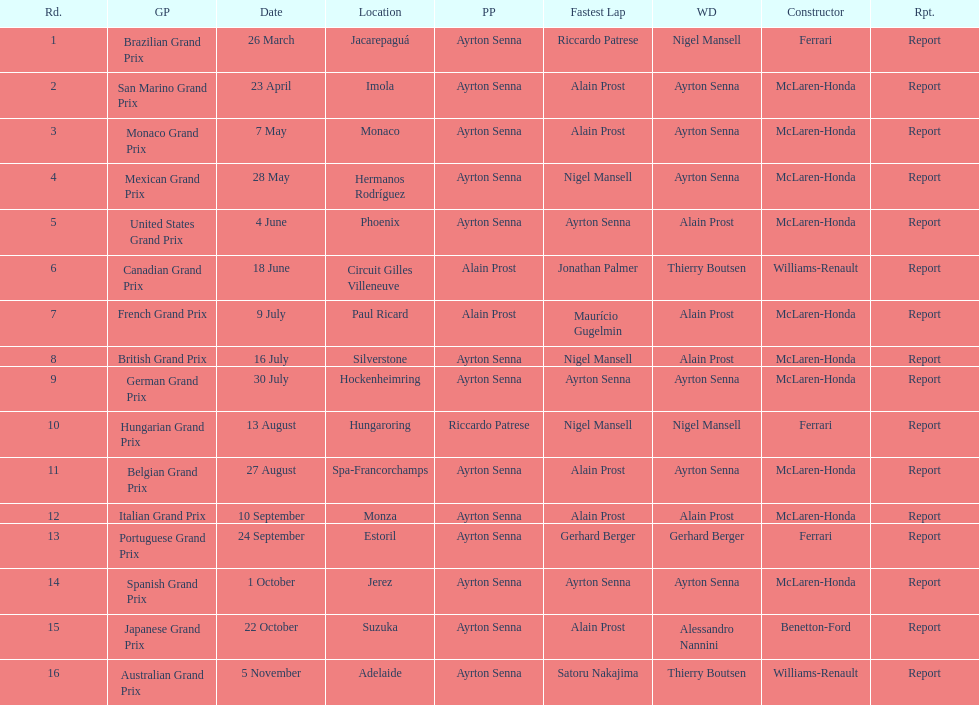What grand prix was before the san marino grand prix? Brazilian Grand Prix. 